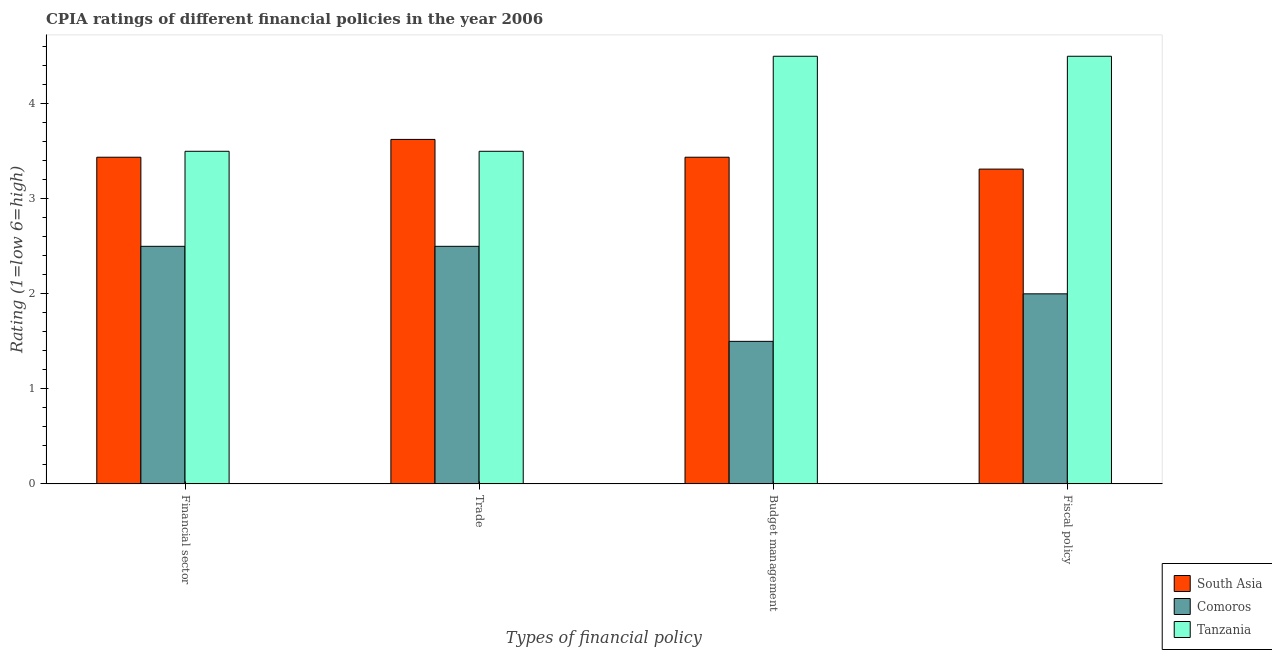How many groups of bars are there?
Offer a terse response. 4. Are the number of bars on each tick of the X-axis equal?
Your response must be concise. Yes. How many bars are there on the 2nd tick from the right?
Keep it short and to the point. 3. What is the label of the 2nd group of bars from the left?
Provide a short and direct response. Trade. What is the cpia rating of financial sector in South Asia?
Make the answer very short. 3.44. Across all countries, what is the minimum cpia rating of fiscal policy?
Make the answer very short. 2. In which country was the cpia rating of trade maximum?
Make the answer very short. South Asia. In which country was the cpia rating of trade minimum?
Your response must be concise. Comoros. What is the total cpia rating of budget management in the graph?
Give a very brief answer. 9.44. What is the difference between the cpia rating of financial sector in Tanzania and that in South Asia?
Your answer should be very brief. 0.06. What is the average cpia rating of budget management per country?
Provide a succinct answer. 3.15. What is the difference between the cpia rating of trade and cpia rating of financial sector in Comoros?
Provide a short and direct response. 0. In how many countries, is the cpia rating of trade greater than 0.4 ?
Offer a very short reply. 3. What is the ratio of the cpia rating of fiscal policy in Tanzania to that in Comoros?
Your answer should be compact. 2.25. Is the cpia rating of fiscal policy in Tanzania less than that in South Asia?
Provide a short and direct response. No. What is the difference between the highest and the second highest cpia rating of fiscal policy?
Provide a succinct answer. 1.19. What is the difference between the highest and the lowest cpia rating of trade?
Your response must be concise. 1.12. Is it the case that in every country, the sum of the cpia rating of budget management and cpia rating of financial sector is greater than the sum of cpia rating of fiscal policy and cpia rating of trade?
Keep it short and to the point. No. What does the 3rd bar from the left in Budget management represents?
Make the answer very short. Tanzania. What does the 1st bar from the right in Fiscal policy represents?
Your response must be concise. Tanzania. Is it the case that in every country, the sum of the cpia rating of financial sector and cpia rating of trade is greater than the cpia rating of budget management?
Offer a very short reply. Yes. How many bars are there?
Your answer should be very brief. 12. Are all the bars in the graph horizontal?
Provide a succinct answer. No. How many countries are there in the graph?
Your answer should be very brief. 3. What is the difference between two consecutive major ticks on the Y-axis?
Provide a short and direct response. 1. Are the values on the major ticks of Y-axis written in scientific E-notation?
Your response must be concise. No. Does the graph contain grids?
Keep it short and to the point. No. Where does the legend appear in the graph?
Provide a succinct answer. Bottom right. How many legend labels are there?
Keep it short and to the point. 3. What is the title of the graph?
Give a very brief answer. CPIA ratings of different financial policies in the year 2006. What is the label or title of the X-axis?
Give a very brief answer. Types of financial policy. What is the label or title of the Y-axis?
Ensure brevity in your answer.  Rating (1=low 6=high). What is the Rating (1=low 6=high) of South Asia in Financial sector?
Keep it short and to the point. 3.44. What is the Rating (1=low 6=high) in South Asia in Trade?
Your response must be concise. 3.62. What is the Rating (1=low 6=high) of Comoros in Trade?
Your response must be concise. 2.5. What is the Rating (1=low 6=high) of South Asia in Budget management?
Make the answer very short. 3.44. What is the Rating (1=low 6=high) in Comoros in Budget management?
Make the answer very short. 1.5. What is the Rating (1=low 6=high) in Tanzania in Budget management?
Offer a very short reply. 4.5. What is the Rating (1=low 6=high) of South Asia in Fiscal policy?
Provide a short and direct response. 3.31. What is the Rating (1=low 6=high) of Comoros in Fiscal policy?
Your response must be concise. 2. What is the Rating (1=low 6=high) of Tanzania in Fiscal policy?
Your answer should be very brief. 4.5. Across all Types of financial policy, what is the maximum Rating (1=low 6=high) in South Asia?
Give a very brief answer. 3.62. Across all Types of financial policy, what is the minimum Rating (1=low 6=high) in South Asia?
Your answer should be compact. 3.31. Across all Types of financial policy, what is the minimum Rating (1=low 6=high) in Comoros?
Keep it short and to the point. 1.5. Across all Types of financial policy, what is the minimum Rating (1=low 6=high) of Tanzania?
Offer a very short reply. 3.5. What is the total Rating (1=low 6=high) of South Asia in the graph?
Provide a succinct answer. 13.81. What is the total Rating (1=low 6=high) of Comoros in the graph?
Ensure brevity in your answer.  8.5. What is the total Rating (1=low 6=high) of Tanzania in the graph?
Make the answer very short. 16. What is the difference between the Rating (1=low 6=high) in South Asia in Financial sector and that in Trade?
Provide a succinct answer. -0.19. What is the difference between the Rating (1=low 6=high) of Comoros in Financial sector and that in Trade?
Keep it short and to the point. 0. What is the difference between the Rating (1=low 6=high) in Tanzania in Financial sector and that in Trade?
Your answer should be compact. 0. What is the difference between the Rating (1=low 6=high) of South Asia in Financial sector and that in Budget management?
Your answer should be compact. 0. What is the difference between the Rating (1=low 6=high) in South Asia in Financial sector and that in Fiscal policy?
Provide a short and direct response. 0.12. What is the difference between the Rating (1=low 6=high) of Comoros in Financial sector and that in Fiscal policy?
Ensure brevity in your answer.  0.5. What is the difference between the Rating (1=low 6=high) in Tanzania in Financial sector and that in Fiscal policy?
Provide a succinct answer. -1. What is the difference between the Rating (1=low 6=high) in South Asia in Trade and that in Budget management?
Your response must be concise. 0.19. What is the difference between the Rating (1=low 6=high) of Comoros in Trade and that in Budget management?
Your answer should be very brief. 1. What is the difference between the Rating (1=low 6=high) in South Asia in Trade and that in Fiscal policy?
Offer a terse response. 0.31. What is the difference between the Rating (1=low 6=high) in Comoros in Budget management and that in Fiscal policy?
Your response must be concise. -0.5. What is the difference between the Rating (1=low 6=high) in South Asia in Financial sector and the Rating (1=low 6=high) in Tanzania in Trade?
Keep it short and to the point. -0.06. What is the difference between the Rating (1=low 6=high) of Comoros in Financial sector and the Rating (1=low 6=high) of Tanzania in Trade?
Offer a very short reply. -1. What is the difference between the Rating (1=low 6=high) of South Asia in Financial sector and the Rating (1=low 6=high) of Comoros in Budget management?
Your answer should be very brief. 1.94. What is the difference between the Rating (1=low 6=high) of South Asia in Financial sector and the Rating (1=low 6=high) of Tanzania in Budget management?
Your response must be concise. -1.06. What is the difference between the Rating (1=low 6=high) of Comoros in Financial sector and the Rating (1=low 6=high) of Tanzania in Budget management?
Offer a terse response. -2. What is the difference between the Rating (1=low 6=high) in South Asia in Financial sector and the Rating (1=low 6=high) in Comoros in Fiscal policy?
Provide a short and direct response. 1.44. What is the difference between the Rating (1=low 6=high) of South Asia in Financial sector and the Rating (1=low 6=high) of Tanzania in Fiscal policy?
Your response must be concise. -1.06. What is the difference between the Rating (1=low 6=high) of Comoros in Financial sector and the Rating (1=low 6=high) of Tanzania in Fiscal policy?
Your answer should be compact. -2. What is the difference between the Rating (1=low 6=high) of South Asia in Trade and the Rating (1=low 6=high) of Comoros in Budget management?
Provide a succinct answer. 2.12. What is the difference between the Rating (1=low 6=high) in South Asia in Trade and the Rating (1=low 6=high) in Tanzania in Budget management?
Your answer should be compact. -0.88. What is the difference between the Rating (1=low 6=high) in South Asia in Trade and the Rating (1=low 6=high) in Comoros in Fiscal policy?
Ensure brevity in your answer.  1.62. What is the difference between the Rating (1=low 6=high) in South Asia in Trade and the Rating (1=low 6=high) in Tanzania in Fiscal policy?
Make the answer very short. -0.88. What is the difference between the Rating (1=low 6=high) of South Asia in Budget management and the Rating (1=low 6=high) of Comoros in Fiscal policy?
Give a very brief answer. 1.44. What is the difference between the Rating (1=low 6=high) in South Asia in Budget management and the Rating (1=low 6=high) in Tanzania in Fiscal policy?
Offer a terse response. -1.06. What is the average Rating (1=low 6=high) of South Asia per Types of financial policy?
Your answer should be compact. 3.45. What is the average Rating (1=low 6=high) of Comoros per Types of financial policy?
Provide a succinct answer. 2.12. What is the difference between the Rating (1=low 6=high) in South Asia and Rating (1=low 6=high) in Comoros in Financial sector?
Your answer should be compact. 0.94. What is the difference between the Rating (1=low 6=high) of South Asia and Rating (1=low 6=high) of Tanzania in Financial sector?
Provide a succinct answer. -0.06. What is the difference between the Rating (1=low 6=high) in South Asia and Rating (1=low 6=high) in Comoros in Trade?
Provide a succinct answer. 1.12. What is the difference between the Rating (1=low 6=high) of South Asia and Rating (1=low 6=high) of Comoros in Budget management?
Give a very brief answer. 1.94. What is the difference between the Rating (1=low 6=high) in South Asia and Rating (1=low 6=high) in Tanzania in Budget management?
Your answer should be compact. -1.06. What is the difference between the Rating (1=low 6=high) in South Asia and Rating (1=low 6=high) in Comoros in Fiscal policy?
Provide a succinct answer. 1.31. What is the difference between the Rating (1=low 6=high) of South Asia and Rating (1=low 6=high) of Tanzania in Fiscal policy?
Give a very brief answer. -1.19. What is the ratio of the Rating (1=low 6=high) in South Asia in Financial sector to that in Trade?
Keep it short and to the point. 0.95. What is the ratio of the Rating (1=low 6=high) in South Asia in Financial sector to that in Fiscal policy?
Your answer should be very brief. 1.04. What is the ratio of the Rating (1=low 6=high) of South Asia in Trade to that in Budget management?
Provide a short and direct response. 1.05. What is the ratio of the Rating (1=low 6=high) of South Asia in Trade to that in Fiscal policy?
Provide a short and direct response. 1.09. What is the ratio of the Rating (1=low 6=high) of Comoros in Trade to that in Fiscal policy?
Give a very brief answer. 1.25. What is the ratio of the Rating (1=low 6=high) of Tanzania in Trade to that in Fiscal policy?
Keep it short and to the point. 0.78. What is the ratio of the Rating (1=low 6=high) in South Asia in Budget management to that in Fiscal policy?
Your answer should be compact. 1.04. What is the difference between the highest and the second highest Rating (1=low 6=high) of South Asia?
Your response must be concise. 0.19. What is the difference between the highest and the lowest Rating (1=low 6=high) of South Asia?
Offer a terse response. 0.31. What is the difference between the highest and the lowest Rating (1=low 6=high) of Tanzania?
Provide a succinct answer. 1. 